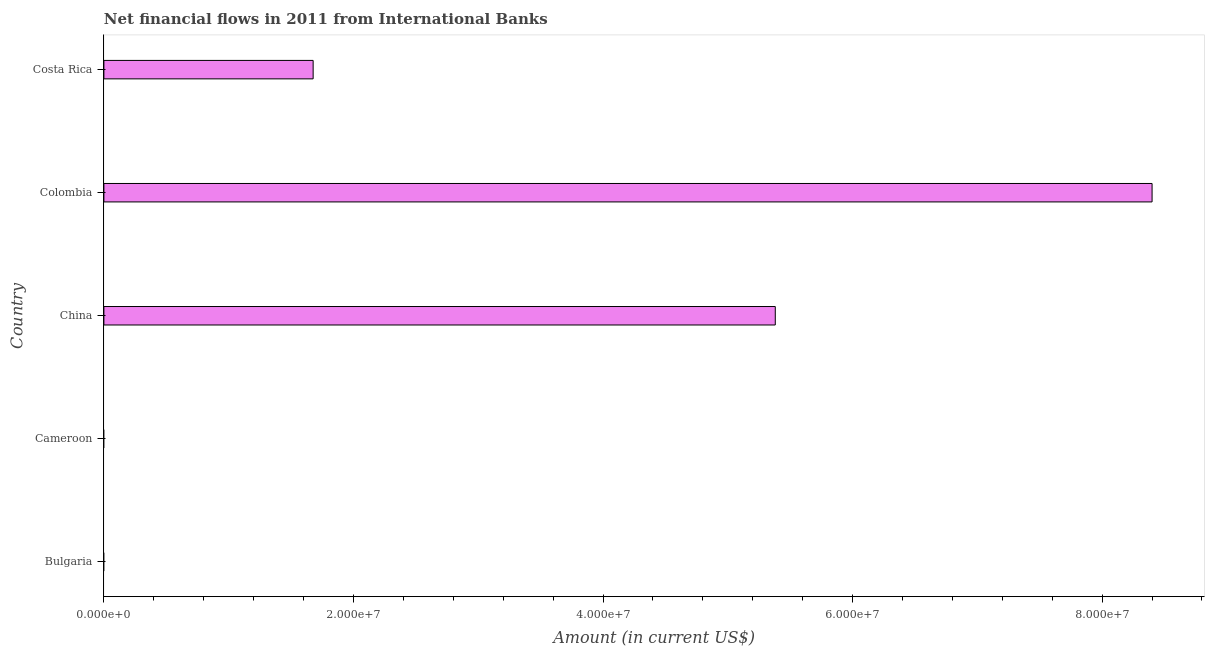Does the graph contain any zero values?
Provide a short and direct response. Yes. What is the title of the graph?
Your answer should be compact. Net financial flows in 2011 from International Banks. What is the label or title of the X-axis?
Your answer should be compact. Amount (in current US$). Across all countries, what is the maximum net financial flows from ibrd?
Provide a succinct answer. 8.40e+07. Across all countries, what is the minimum net financial flows from ibrd?
Provide a succinct answer. 0. What is the sum of the net financial flows from ibrd?
Your answer should be compact. 1.55e+08. What is the difference between the net financial flows from ibrd in China and Costa Rica?
Provide a succinct answer. 3.70e+07. What is the average net financial flows from ibrd per country?
Give a very brief answer. 3.09e+07. What is the median net financial flows from ibrd?
Give a very brief answer. 1.68e+07. In how many countries, is the net financial flows from ibrd greater than 28000000 US$?
Ensure brevity in your answer.  2. What is the ratio of the net financial flows from ibrd in China to that in Costa Rica?
Keep it short and to the point. 3.21. Is the net financial flows from ibrd in China less than that in Costa Rica?
Offer a very short reply. No. Is the difference between the net financial flows from ibrd in China and Costa Rica greater than the difference between any two countries?
Offer a very short reply. No. What is the difference between the highest and the second highest net financial flows from ibrd?
Offer a very short reply. 3.02e+07. Is the sum of the net financial flows from ibrd in China and Colombia greater than the maximum net financial flows from ibrd across all countries?
Your response must be concise. Yes. What is the difference between the highest and the lowest net financial flows from ibrd?
Make the answer very short. 8.40e+07. Are all the bars in the graph horizontal?
Provide a short and direct response. Yes. Are the values on the major ticks of X-axis written in scientific E-notation?
Your answer should be compact. Yes. What is the Amount (in current US$) of Cameroon?
Offer a terse response. 0. What is the Amount (in current US$) of China?
Give a very brief answer. 5.38e+07. What is the Amount (in current US$) in Colombia?
Ensure brevity in your answer.  8.40e+07. What is the Amount (in current US$) of Costa Rica?
Provide a short and direct response. 1.68e+07. What is the difference between the Amount (in current US$) in China and Colombia?
Your answer should be very brief. -3.02e+07. What is the difference between the Amount (in current US$) in China and Costa Rica?
Offer a terse response. 3.70e+07. What is the difference between the Amount (in current US$) in Colombia and Costa Rica?
Offer a very short reply. 6.72e+07. What is the ratio of the Amount (in current US$) in China to that in Colombia?
Your response must be concise. 0.64. What is the ratio of the Amount (in current US$) in China to that in Costa Rica?
Ensure brevity in your answer.  3.21. What is the ratio of the Amount (in current US$) in Colombia to that in Costa Rica?
Keep it short and to the point. 5.01. 